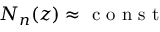<formula> <loc_0><loc_0><loc_500><loc_500>N _ { n } ( z ) \approx c o n s t</formula> 